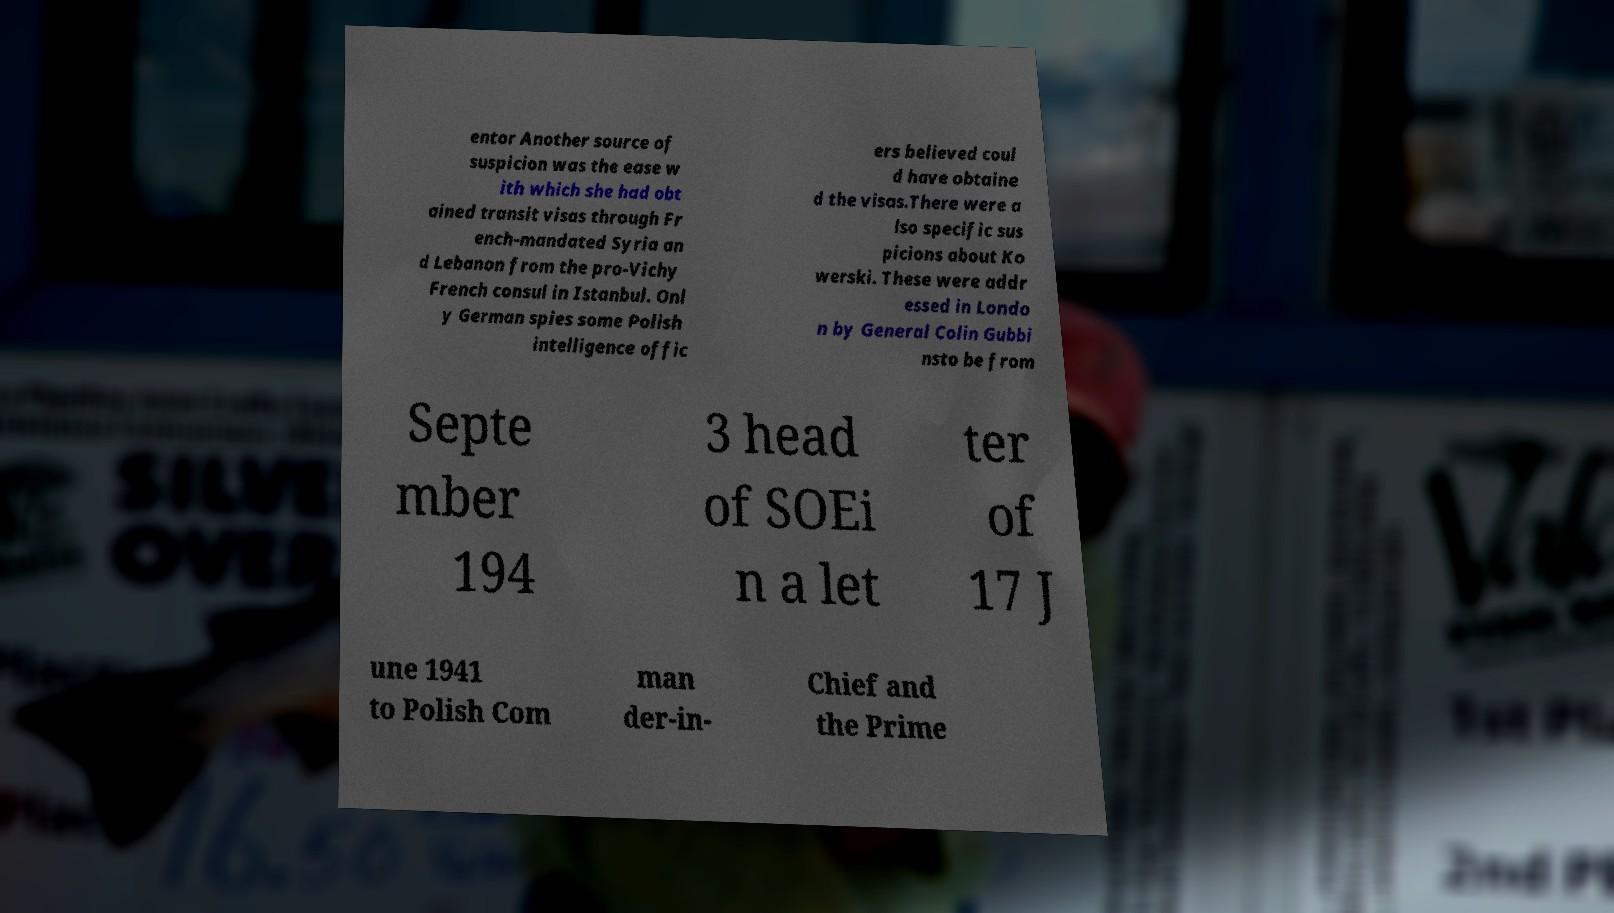I need the written content from this picture converted into text. Can you do that? entor Another source of suspicion was the ease w ith which she had obt ained transit visas through Fr ench-mandated Syria an d Lebanon from the pro-Vichy French consul in Istanbul. Onl y German spies some Polish intelligence offic ers believed coul d have obtaine d the visas.There were a lso specific sus picions about Ko werski. These were addr essed in Londo n by General Colin Gubbi nsto be from Septe mber 194 3 head of SOEi n a let ter of 17 J une 1941 to Polish Com man der-in- Chief and the Prime 